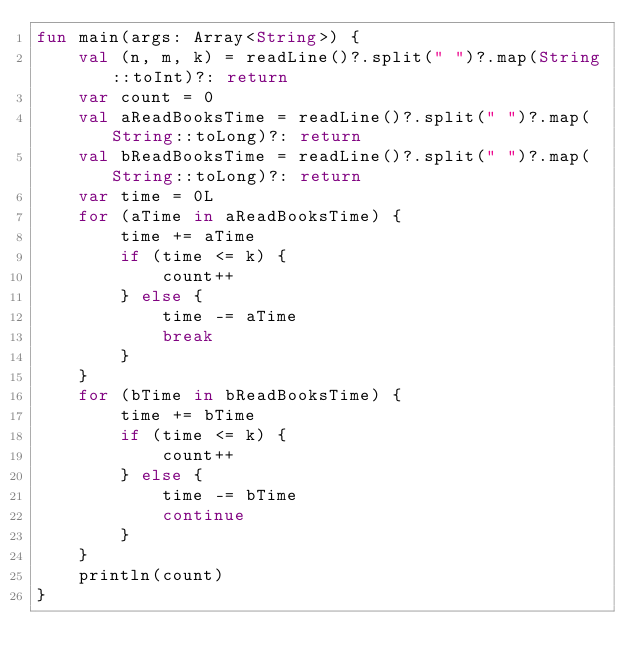Convert code to text. <code><loc_0><loc_0><loc_500><loc_500><_Kotlin_>fun main(args: Array<String>) {
    val (n, m, k) = readLine()?.split(" ")?.map(String::toInt)?: return
    var count = 0
    val aReadBooksTime = readLine()?.split(" ")?.map(String::toLong)?: return
    val bReadBooksTime = readLine()?.split(" ")?.map(String::toLong)?: return
    var time = 0L
    for (aTime in aReadBooksTime) {
        time += aTime
        if (time <= k) {
            count++
        } else {
            time -= aTime
            break
        }
    }
    for (bTime in bReadBooksTime) {
        time += bTime
        if (time <= k) {
            count++
        } else {
            time -= bTime
            continue
        }
    }
    println(count)
}</code> 